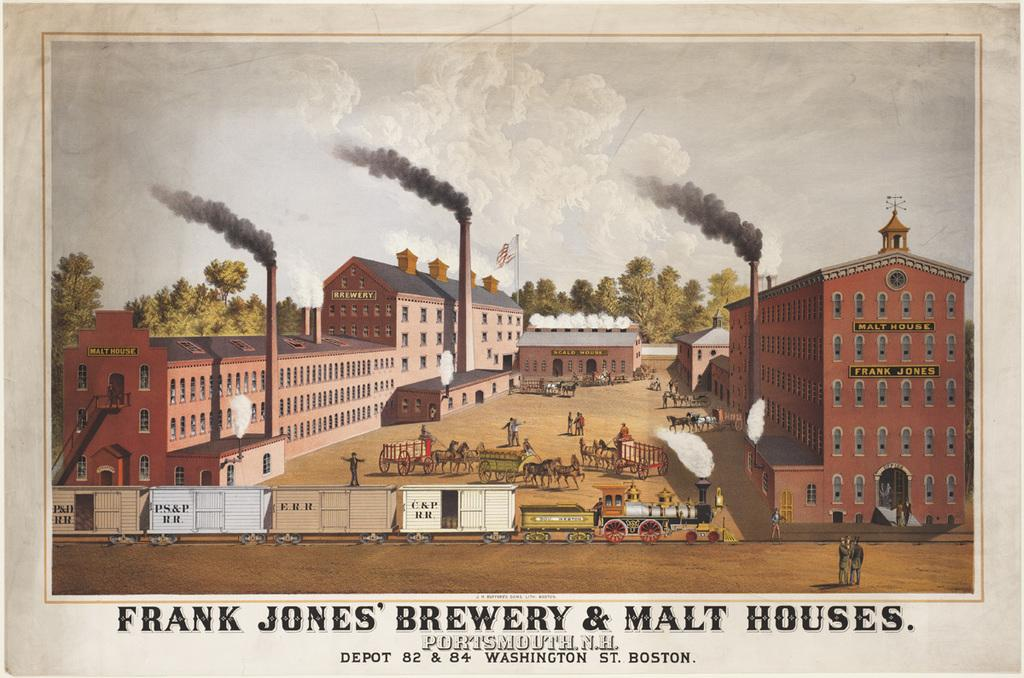<image>
Present a compact description of the photo's key features. The old buildings of Frank Jones' brewery and Malt houses 